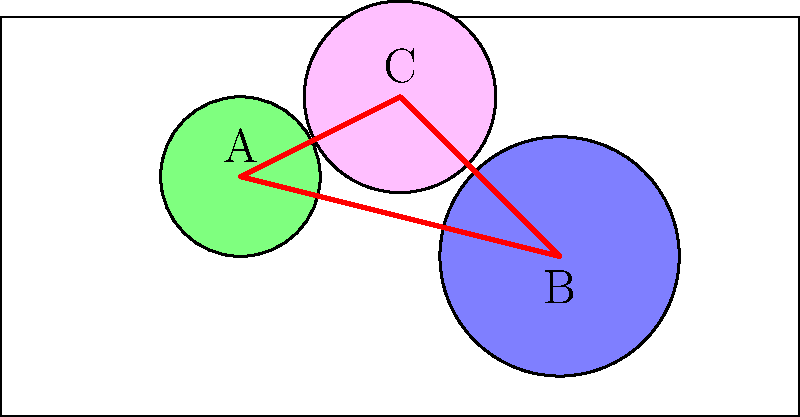Consider the topological space representing the geographical distribution of women's contributions to military efforts worldwide, as shown in the figure. The colored regions A, B, and C represent areas of significant contributions, while the red paths indicate connections between these regions. What is the rank of the fundamental group of this space? To determine the rank of the fundamental group of this space, we'll follow these steps:

1) First, observe that the space can be simplified to a graph with three vertices (A, B, and C) and three edges connecting them.

2) This simplified graph is homotopy equivalent to the original space, so their fundamental groups are isomorphic.

3) The resulting graph is homeomorphic to a circle $S^1$.

4) Recall that the fundamental group of a circle is isomorphic to the integers $\mathbb{Z}$, i.e., $\pi_1(S^1) \cong \mathbb{Z}$.

5) The rank of a group is the minimum number of elements needed to generate the group. For $\mathbb{Z}$, this is 1, as all integers can be generated by repeated addition or subtraction of 1.

Therefore, the rank of the fundamental group of this space is 1.
Answer: 1 